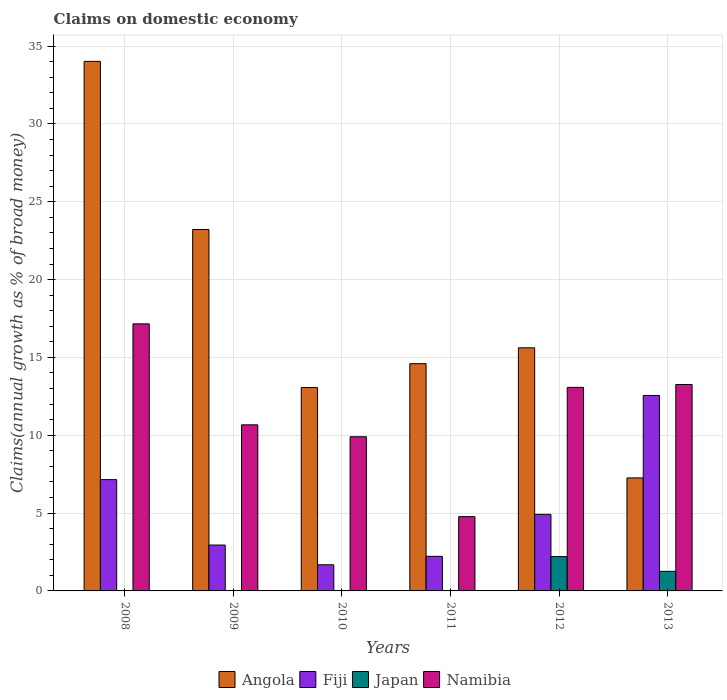In how many cases, is the number of bars for a given year not equal to the number of legend labels?
Ensure brevity in your answer.  4. What is the percentage of broad money claimed on domestic economy in Angola in 2012?
Provide a succinct answer. 15.62. Across all years, what is the maximum percentage of broad money claimed on domestic economy in Angola?
Your answer should be very brief. 34.02. Across all years, what is the minimum percentage of broad money claimed on domestic economy in Namibia?
Keep it short and to the point. 4.77. In which year was the percentage of broad money claimed on domestic economy in Namibia maximum?
Offer a terse response. 2008. What is the total percentage of broad money claimed on domestic economy in Fiji in the graph?
Ensure brevity in your answer.  31.47. What is the difference between the percentage of broad money claimed on domestic economy in Angola in 2010 and that in 2011?
Offer a terse response. -1.53. What is the difference between the percentage of broad money claimed on domestic economy in Fiji in 2008 and the percentage of broad money claimed on domestic economy in Namibia in 2009?
Ensure brevity in your answer.  -3.52. What is the average percentage of broad money claimed on domestic economy in Fiji per year?
Provide a short and direct response. 5.25. In the year 2013, what is the difference between the percentage of broad money claimed on domestic economy in Namibia and percentage of broad money claimed on domestic economy in Japan?
Make the answer very short. 12. In how many years, is the percentage of broad money claimed on domestic economy in Namibia greater than 24 %?
Ensure brevity in your answer.  0. What is the ratio of the percentage of broad money claimed on domestic economy in Namibia in 2009 to that in 2013?
Ensure brevity in your answer.  0.8. Is the percentage of broad money claimed on domestic economy in Namibia in 2010 less than that in 2011?
Ensure brevity in your answer.  No. What is the difference between the highest and the second highest percentage of broad money claimed on domestic economy in Namibia?
Your response must be concise. 3.9. What is the difference between the highest and the lowest percentage of broad money claimed on domestic economy in Angola?
Offer a terse response. 26.76. Is the sum of the percentage of broad money claimed on domestic economy in Fiji in 2012 and 2013 greater than the maximum percentage of broad money claimed on domestic economy in Japan across all years?
Provide a short and direct response. Yes. Is it the case that in every year, the sum of the percentage of broad money claimed on domestic economy in Japan and percentage of broad money claimed on domestic economy in Angola is greater than the sum of percentage of broad money claimed on domestic economy in Fiji and percentage of broad money claimed on domestic economy in Namibia?
Your response must be concise. Yes. How many bars are there?
Provide a succinct answer. 20. How many legend labels are there?
Your answer should be compact. 4. What is the title of the graph?
Provide a succinct answer. Claims on domestic economy. What is the label or title of the X-axis?
Provide a succinct answer. Years. What is the label or title of the Y-axis?
Your response must be concise. Claims(annual growth as % of broad money). What is the Claims(annual growth as % of broad money) of Angola in 2008?
Your response must be concise. 34.02. What is the Claims(annual growth as % of broad money) of Fiji in 2008?
Ensure brevity in your answer.  7.15. What is the Claims(annual growth as % of broad money) of Japan in 2008?
Your response must be concise. 0. What is the Claims(annual growth as % of broad money) in Namibia in 2008?
Your response must be concise. 17.15. What is the Claims(annual growth as % of broad money) of Angola in 2009?
Offer a very short reply. 23.22. What is the Claims(annual growth as % of broad money) of Fiji in 2009?
Ensure brevity in your answer.  2.95. What is the Claims(annual growth as % of broad money) of Japan in 2009?
Your answer should be compact. 0. What is the Claims(annual growth as % of broad money) in Namibia in 2009?
Provide a succinct answer. 10.67. What is the Claims(annual growth as % of broad money) in Angola in 2010?
Keep it short and to the point. 13.06. What is the Claims(annual growth as % of broad money) of Fiji in 2010?
Provide a short and direct response. 1.68. What is the Claims(annual growth as % of broad money) in Japan in 2010?
Give a very brief answer. 0. What is the Claims(annual growth as % of broad money) in Namibia in 2010?
Give a very brief answer. 9.9. What is the Claims(annual growth as % of broad money) of Angola in 2011?
Keep it short and to the point. 14.6. What is the Claims(annual growth as % of broad money) of Fiji in 2011?
Your response must be concise. 2.22. What is the Claims(annual growth as % of broad money) of Namibia in 2011?
Ensure brevity in your answer.  4.77. What is the Claims(annual growth as % of broad money) of Angola in 2012?
Your response must be concise. 15.62. What is the Claims(annual growth as % of broad money) in Fiji in 2012?
Provide a short and direct response. 4.92. What is the Claims(annual growth as % of broad money) in Japan in 2012?
Make the answer very short. 2.21. What is the Claims(annual growth as % of broad money) of Namibia in 2012?
Offer a terse response. 13.08. What is the Claims(annual growth as % of broad money) in Angola in 2013?
Keep it short and to the point. 7.26. What is the Claims(annual growth as % of broad money) of Fiji in 2013?
Provide a short and direct response. 12.56. What is the Claims(annual growth as % of broad money) in Japan in 2013?
Provide a succinct answer. 1.26. What is the Claims(annual growth as % of broad money) of Namibia in 2013?
Provide a short and direct response. 13.26. Across all years, what is the maximum Claims(annual growth as % of broad money) in Angola?
Your answer should be compact. 34.02. Across all years, what is the maximum Claims(annual growth as % of broad money) in Fiji?
Your answer should be compact. 12.56. Across all years, what is the maximum Claims(annual growth as % of broad money) of Japan?
Your answer should be very brief. 2.21. Across all years, what is the maximum Claims(annual growth as % of broad money) of Namibia?
Provide a succinct answer. 17.15. Across all years, what is the minimum Claims(annual growth as % of broad money) in Angola?
Offer a terse response. 7.26. Across all years, what is the minimum Claims(annual growth as % of broad money) of Fiji?
Keep it short and to the point. 1.68. Across all years, what is the minimum Claims(annual growth as % of broad money) of Japan?
Your answer should be compact. 0. Across all years, what is the minimum Claims(annual growth as % of broad money) of Namibia?
Provide a short and direct response. 4.77. What is the total Claims(annual growth as % of broad money) of Angola in the graph?
Keep it short and to the point. 107.77. What is the total Claims(annual growth as % of broad money) in Fiji in the graph?
Your answer should be very brief. 31.47. What is the total Claims(annual growth as % of broad money) of Japan in the graph?
Your answer should be compact. 3.46. What is the total Claims(annual growth as % of broad money) of Namibia in the graph?
Offer a very short reply. 68.83. What is the difference between the Claims(annual growth as % of broad money) of Angola in 2008 and that in 2009?
Your answer should be compact. 10.8. What is the difference between the Claims(annual growth as % of broad money) in Fiji in 2008 and that in 2009?
Your answer should be very brief. 4.2. What is the difference between the Claims(annual growth as % of broad money) of Namibia in 2008 and that in 2009?
Give a very brief answer. 6.49. What is the difference between the Claims(annual growth as % of broad money) in Angola in 2008 and that in 2010?
Provide a short and direct response. 20.95. What is the difference between the Claims(annual growth as % of broad money) in Fiji in 2008 and that in 2010?
Your answer should be very brief. 5.47. What is the difference between the Claims(annual growth as % of broad money) of Namibia in 2008 and that in 2010?
Your answer should be compact. 7.25. What is the difference between the Claims(annual growth as % of broad money) of Angola in 2008 and that in 2011?
Give a very brief answer. 19.42. What is the difference between the Claims(annual growth as % of broad money) of Fiji in 2008 and that in 2011?
Your answer should be compact. 4.93. What is the difference between the Claims(annual growth as % of broad money) of Namibia in 2008 and that in 2011?
Ensure brevity in your answer.  12.38. What is the difference between the Claims(annual growth as % of broad money) in Angola in 2008 and that in 2012?
Give a very brief answer. 18.4. What is the difference between the Claims(annual growth as % of broad money) of Fiji in 2008 and that in 2012?
Offer a terse response. 2.23. What is the difference between the Claims(annual growth as % of broad money) of Namibia in 2008 and that in 2012?
Offer a terse response. 4.08. What is the difference between the Claims(annual growth as % of broad money) of Angola in 2008 and that in 2013?
Your response must be concise. 26.76. What is the difference between the Claims(annual growth as % of broad money) of Fiji in 2008 and that in 2013?
Provide a succinct answer. -5.41. What is the difference between the Claims(annual growth as % of broad money) of Namibia in 2008 and that in 2013?
Your answer should be very brief. 3.9. What is the difference between the Claims(annual growth as % of broad money) in Angola in 2009 and that in 2010?
Your response must be concise. 10.15. What is the difference between the Claims(annual growth as % of broad money) of Fiji in 2009 and that in 2010?
Provide a succinct answer. 1.27. What is the difference between the Claims(annual growth as % of broad money) of Namibia in 2009 and that in 2010?
Your response must be concise. 0.77. What is the difference between the Claims(annual growth as % of broad money) of Angola in 2009 and that in 2011?
Keep it short and to the point. 8.62. What is the difference between the Claims(annual growth as % of broad money) in Fiji in 2009 and that in 2011?
Provide a short and direct response. 0.72. What is the difference between the Claims(annual growth as % of broad money) of Namibia in 2009 and that in 2011?
Give a very brief answer. 5.9. What is the difference between the Claims(annual growth as % of broad money) in Angola in 2009 and that in 2012?
Provide a short and direct response. 7.6. What is the difference between the Claims(annual growth as % of broad money) of Fiji in 2009 and that in 2012?
Make the answer very short. -1.97. What is the difference between the Claims(annual growth as % of broad money) of Namibia in 2009 and that in 2012?
Keep it short and to the point. -2.41. What is the difference between the Claims(annual growth as % of broad money) in Angola in 2009 and that in 2013?
Give a very brief answer. 15.96. What is the difference between the Claims(annual growth as % of broad money) in Fiji in 2009 and that in 2013?
Keep it short and to the point. -9.61. What is the difference between the Claims(annual growth as % of broad money) in Namibia in 2009 and that in 2013?
Give a very brief answer. -2.59. What is the difference between the Claims(annual growth as % of broad money) in Angola in 2010 and that in 2011?
Provide a succinct answer. -1.53. What is the difference between the Claims(annual growth as % of broad money) of Fiji in 2010 and that in 2011?
Your response must be concise. -0.54. What is the difference between the Claims(annual growth as % of broad money) of Namibia in 2010 and that in 2011?
Ensure brevity in your answer.  5.13. What is the difference between the Claims(annual growth as % of broad money) in Angola in 2010 and that in 2012?
Make the answer very short. -2.55. What is the difference between the Claims(annual growth as % of broad money) in Fiji in 2010 and that in 2012?
Your answer should be compact. -3.24. What is the difference between the Claims(annual growth as % of broad money) of Namibia in 2010 and that in 2012?
Your response must be concise. -3.17. What is the difference between the Claims(annual growth as % of broad money) of Angola in 2010 and that in 2013?
Offer a terse response. 5.8. What is the difference between the Claims(annual growth as % of broad money) in Fiji in 2010 and that in 2013?
Make the answer very short. -10.88. What is the difference between the Claims(annual growth as % of broad money) in Namibia in 2010 and that in 2013?
Your response must be concise. -3.35. What is the difference between the Claims(annual growth as % of broad money) in Angola in 2011 and that in 2012?
Provide a succinct answer. -1.02. What is the difference between the Claims(annual growth as % of broad money) of Fiji in 2011 and that in 2012?
Provide a short and direct response. -2.7. What is the difference between the Claims(annual growth as % of broad money) in Namibia in 2011 and that in 2012?
Keep it short and to the point. -8.3. What is the difference between the Claims(annual growth as % of broad money) in Angola in 2011 and that in 2013?
Give a very brief answer. 7.34. What is the difference between the Claims(annual growth as % of broad money) of Fiji in 2011 and that in 2013?
Make the answer very short. -10.33. What is the difference between the Claims(annual growth as % of broad money) in Namibia in 2011 and that in 2013?
Keep it short and to the point. -8.49. What is the difference between the Claims(annual growth as % of broad money) of Angola in 2012 and that in 2013?
Offer a very short reply. 8.36. What is the difference between the Claims(annual growth as % of broad money) of Fiji in 2012 and that in 2013?
Your response must be concise. -7.64. What is the difference between the Claims(annual growth as % of broad money) of Japan in 2012 and that in 2013?
Make the answer very short. 0.95. What is the difference between the Claims(annual growth as % of broad money) in Namibia in 2012 and that in 2013?
Your response must be concise. -0.18. What is the difference between the Claims(annual growth as % of broad money) in Angola in 2008 and the Claims(annual growth as % of broad money) in Fiji in 2009?
Your answer should be very brief. 31.07. What is the difference between the Claims(annual growth as % of broad money) in Angola in 2008 and the Claims(annual growth as % of broad money) in Namibia in 2009?
Offer a terse response. 23.35. What is the difference between the Claims(annual growth as % of broad money) of Fiji in 2008 and the Claims(annual growth as % of broad money) of Namibia in 2009?
Provide a short and direct response. -3.52. What is the difference between the Claims(annual growth as % of broad money) in Angola in 2008 and the Claims(annual growth as % of broad money) in Fiji in 2010?
Your answer should be compact. 32.34. What is the difference between the Claims(annual growth as % of broad money) of Angola in 2008 and the Claims(annual growth as % of broad money) of Namibia in 2010?
Make the answer very short. 24.11. What is the difference between the Claims(annual growth as % of broad money) of Fiji in 2008 and the Claims(annual growth as % of broad money) of Namibia in 2010?
Your response must be concise. -2.75. What is the difference between the Claims(annual growth as % of broad money) in Angola in 2008 and the Claims(annual growth as % of broad money) in Fiji in 2011?
Make the answer very short. 31.8. What is the difference between the Claims(annual growth as % of broad money) in Angola in 2008 and the Claims(annual growth as % of broad money) in Namibia in 2011?
Provide a succinct answer. 29.25. What is the difference between the Claims(annual growth as % of broad money) in Fiji in 2008 and the Claims(annual growth as % of broad money) in Namibia in 2011?
Keep it short and to the point. 2.38. What is the difference between the Claims(annual growth as % of broad money) in Angola in 2008 and the Claims(annual growth as % of broad money) in Fiji in 2012?
Provide a succinct answer. 29.1. What is the difference between the Claims(annual growth as % of broad money) of Angola in 2008 and the Claims(annual growth as % of broad money) of Japan in 2012?
Offer a terse response. 31.81. What is the difference between the Claims(annual growth as % of broad money) of Angola in 2008 and the Claims(annual growth as % of broad money) of Namibia in 2012?
Provide a succinct answer. 20.94. What is the difference between the Claims(annual growth as % of broad money) of Fiji in 2008 and the Claims(annual growth as % of broad money) of Japan in 2012?
Provide a short and direct response. 4.94. What is the difference between the Claims(annual growth as % of broad money) of Fiji in 2008 and the Claims(annual growth as % of broad money) of Namibia in 2012?
Your response must be concise. -5.93. What is the difference between the Claims(annual growth as % of broad money) in Angola in 2008 and the Claims(annual growth as % of broad money) in Fiji in 2013?
Your response must be concise. 21.46. What is the difference between the Claims(annual growth as % of broad money) of Angola in 2008 and the Claims(annual growth as % of broad money) of Japan in 2013?
Your answer should be compact. 32.76. What is the difference between the Claims(annual growth as % of broad money) of Angola in 2008 and the Claims(annual growth as % of broad money) of Namibia in 2013?
Your response must be concise. 20.76. What is the difference between the Claims(annual growth as % of broad money) in Fiji in 2008 and the Claims(annual growth as % of broad money) in Japan in 2013?
Your answer should be very brief. 5.89. What is the difference between the Claims(annual growth as % of broad money) in Fiji in 2008 and the Claims(annual growth as % of broad money) in Namibia in 2013?
Make the answer very short. -6.11. What is the difference between the Claims(annual growth as % of broad money) of Angola in 2009 and the Claims(annual growth as % of broad money) of Fiji in 2010?
Make the answer very short. 21.54. What is the difference between the Claims(annual growth as % of broad money) in Angola in 2009 and the Claims(annual growth as % of broad money) in Namibia in 2010?
Offer a very short reply. 13.31. What is the difference between the Claims(annual growth as % of broad money) in Fiji in 2009 and the Claims(annual growth as % of broad money) in Namibia in 2010?
Offer a very short reply. -6.96. What is the difference between the Claims(annual growth as % of broad money) of Angola in 2009 and the Claims(annual growth as % of broad money) of Fiji in 2011?
Offer a very short reply. 20.99. What is the difference between the Claims(annual growth as % of broad money) of Angola in 2009 and the Claims(annual growth as % of broad money) of Namibia in 2011?
Provide a short and direct response. 18.45. What is the difference between the Claims(annual growth as % of broad money) of Fiji in 2009 and the Claims(annual growth as % of broad money) of Namibia in 2011?
Your answer should be compact. -1.82. What is the difference between the Claims(annual growth as % of broad money) in Angola in 2009 and the Claims(annual growth as % of broad money) in Fiji in 2012?
Your answer should be compact. 18.3. What is the difference between the Claims(annual growth as % of broad money) in Angola in 2009 and the Claims(annual growth as % of broad money) in Japan in 2012?
Provide a succinct answer. 21.01. What is the difference between the Claims(annual growth as % of broad money) of Angola in 2009 and the Claims(annual growth as % of broad money) of Namibia in 2012?
Your answer should be compact. 10.14. What is the difference between the Claims(annual growth as % of broad money) of Fiji in 2009 and the Claims(annual growth as % of broad money) of Japan in 2012?
Your answer should be very brief. 0.74. What is the difference between the Claims(annual growth as % of broad money) in Fiji in 2009 and the Claims(annual growth as % of broad money) in Namibia in 2012?
Your response must be concise. -10.13. What is the difference between the Claims(annual growth as % of broad money) in Angola in 2009 and the Claims(annual growth as % of broad money) in Fiji in 2013?
Offer a very short reply. 10.66. What is the difference between the Claims(annual growth as % of broad money) in Angola in 2009 and the Claims(annual growth as % of broad money) in Japan in 2013?
Provide a short and direct response. 21.96. What is the difference between the Claims(annual growth as % of broad money) in Angola in 2009 and the Claims(annual growth as % of broad money) in Namibia in 2013?
Your answer should be compact. 9.96. What is the difference between the Claims(annual growth as % of broad money) of Fiji in 2009 and the Claims(annual growth as % of broad money) of Japan in 2013?
Provide a short and direct response. 1.69. What is the difference between the Claims(annual growth as % of broad money) of Fiji in 2009 and the Claims(annual growth as % of broad money) of Namibia in 2013?
Your response must be concise. -10.31. What is the difference between the Claims(annual growth as % of broad money) of Angola in 2010 and the Claims(annual growth as % of broad money) of Fiji in 2011?
Your answer should be compact. 10.84. What is the difference between the Claims(annual growth as % of broad money) in Angola in 2010 and the Claims(annual growth as % of broad money) in Namibia in 2011?
Provide a succinct answer. 8.29. What is the difference between the Claims(annual growth as % of broad money) in Fiji in 2010 and the Claims(annual growth as % of broad money) in Namibia in 2011?
Give a very brief answer. -3.09. What is the difference between the Claims(annual growth as % of broad money) in Angola in 2010 and the Claims(annual growth as % of broad money) in Fiji in 2012?
Offer a very short reply. 8.14. What is the difference between the Claims(annual growth as % of broad money) of Angola in 2010 and the Claims(annual growth as % of broad money) of Japan in 2012?
Your answer should be very brief. 10.86. What is the difference between the Claims(annual growth as % of broad money) of Angola in 2010 and the Claims(annual growth as % of broad money) of Namibia in 2012?
Your response must be concise. -0.01. What is the difference between the Claims(annual growth as % of broad money) in Fiji in 2010 and the Claims(annual growth as % of broad money) in Japan in 2012?
Provide a short and direct response. -0.53. What is the difference between the Claims(annual growth as % of broad money) in Fiji in 2010 and the Claims(annual growth as % of broad money) in Namibia in 2012?
Your answer should be very brief. -11.4. What is the difference between the Claims(annual growth as % of broad money) of Angola in 2010 and the Claims(annual growth as % of broad money) of Fiji in 2013?
Provide a short and direct response. 0.51. What is the difference between the Claims(annual growth as % of broad money) of Angola in 2010 and the Claims(annual growth as % of broad money) of Japan in 2013?
Your response must be concise. 11.8. What is the difference between the Claims(annual growth as % of broad money) in Angola in 2010 and the Claims(annual growth as % of broad money) in Namibia in 2013?
Offer a very short reply. -0.2. What is the difference between the Claims(annual growth as % of broad money) in Fiji in 2010 and the Claims(annual growth as % of broad money) in Japan in 2013?
Your answer should be compact. 0.42. What is the difference between the Claims(annual growth as % of broad money) in Fiji in 2010 and the Claims(annual growth as % of broad money) in Namibia in 2013?
Make the answer very short. -11.58. What is the difference between the Claims(annual growth as % of broad money) in Angola in 2011 and the Claims(annual growth as % of broad money) in Fiji in 2012?
Make the answer very short. 9.68. What is the difference between the Claims(annual growth as % of broad money) in Angola in 2011 and the Claims(annual growth as % of broad money) in Japan in 2012?
Provide a succinct answer. 12.39. What is the difference between the Claims(annual growth as % of broad money) in Angola in 2011 and the Claims(annual growth as % of broad money) in Namibia in 2012?
Ensure brevity in your answer.  1.52. What is the difference between the Claims(annual growth as % of broad money) in Fiji in 2011 and the Claims(annual growth as % of broad money) in Japan in 2012?
Keep it short and to the point. 0.02. What is the difference between the Claims(annual growth as % of broad money) of Fiji in 2011 and the Claims(annual growth as % of broad money) of Namibia in 2012?
Your response must be concise. -10.85. What is the difference between the Claims(annual growth as % of broad money) in Angola in 2011 and the Claims(annual growth as % of broad money) in Fiji in 2013?
Make the answer very short. 2.04. What is the difference between the Claims(annual growth as % of broad money) in Angola in 2011 and the Claims(annual growth as % of broad money) in Japan in 2013?
Your response must be concise. 13.34. What is the difference between the Claims(annual growth as % of broad money) of Angola in 2011 and the Claims(annual growth as % of broad money) of Namibia in 2013?
Provide a succinct answer. 1.34. What is the difference between the Claims(annual growth as % of broad money) of Fiji in 2011 and the Claims(annual growth as % of broad money) of Japan in 2013?
Your response must be concise. 0.96. What is the difference between the Claims(annual growth as % of broad money) of Fiji in 2011 and the Claims(annual growth as % of broad money) of Namibia in 2013?
Ensure brevity in your answer.  -11.04. What is the difference between the Claims(annual growth as % of broad money) of Angola in 2012 and the Claims(annual growth as % of broad money) of Fiji in 2013?
Keep it short and to the point. 3.06. What is the difference between the Claims(annual growth as % of broad money) of Angola in 2012 and the Claims(annual growth as % of broad money) of Japan in 2013?
Ensure brevity in your answer.  14.36. What is the difference between the Claims(annual growth as % of broad money) in Angola in 2012 and the Claims(annual growth as % of broad money) in Namibia in 2013?
Give a very brief answer. 2.36. What is the difference between the Claims(annual growth as % of broad money) of Fiji in 2012 and the Claims(annual growth as % of broad money) of Japan in 2013?
Keep it short and to the point. 3.66. What is the difference between the Claims(annual growth as % of broad money) in Fiji in 2012 and the Claims(annual growth as % of broad money) in Namibia in 2013?
Your response must be concise. -8.34. What is the difference between the Claims(annual growth as % of broad money) of Japan in 2012 and the Claims(annual growth as % of broad money) of Namibia in 2013?
Provide a short and direct response. -11.05. What is the average Claims(annual growth as % of broad money) in Angola per year?
Ensure brevity in your answer.  17.96. What is the average Claims(annual growth as % of broad money) of Fiji per year?
Offer a very short reply. 5.25. What is the average Claims(annual growth as % of broad money) of Japan per year?
Keep it short and to the point. 0.58. What is the average Claims(annual growth as % of broad money) of Namibia per year?
Provide a succinct answer. 11.47. In the year 2008, what is the difference between the Claims(annual growth as % of broad money) in Angola and Claims(annual growth as % of broad money) in Fiji?
Offer a terse response. 26.87. In the year 2008, what is the difference between the Claims(annual growth as % of broad money) of Angola and Claims(annual growth as % of broad money) of Namibia?
Offer a very short reply. 16.86. In the year 2008, what is the difference between the Claims(annual growth as % of broad money) of Fiji and Claims(annual growth as % of broad money) of Namibia?
Ensure brevity in your answer.  -10. In the year 2009, what is the difference between the Claims(annual growth as % of broad money) in Angola and Claims(annual growth as % of broad money) in Fiji?
Offer a very short reply. 20.27. In the year 2009, what is the difference between the Claims(annual growth as % of broad money) of Angola and Claims(annual growth as % of broad money) of Namibia?
Your response must be concise. 12.55. In the year 2009, what is the difference between the Claims(annual growth as % of broad money) of Fiji and Claims(annual growth as % of broad money) of Namibia?
Offer a very short reply. -7.72. In the year 2010, what is the difference between the Claims(annual growth as % of broad money) in Angola and Claims(annual growth as % of broad money) in Fiji?
Offer a very short reply. 11.38. In the year 2010, what is the difference between the Claims(annual growth as % of broad money) in Angola and Claims(annual growth as % of broad money) in Namibia?
Provide a short and direct response. 3.16. In the year 2010, what is the difference between the Claims(annual growth as % of broad money) of Fiji and Claims(annual growth as % of broad money) of Namibia?
Provide a short and direct response. -8.22. In the year 2011, what is the difference between the Claims(annual growth as % of broad money) in Angola and Claims(annual growth as % of broad money) in Fiji?
Offer a terse response. 12.37. In the year 2011, what is the difference between the Claims(annual growth as % of broad money) of Angola and Claims(annual growth as % of broad money) of Namibia?
Provide a short and direct response. 9.83. In the year 2011, what is the difference between the Claims(annual growth as % of broad money) in Fiji and Claims(annual growth as % of broad money) in Namibia?
Your answer should be compact. -2.55. In the year 2012, what is the difference between the Claims(annual growth as % of broad money) of Angola and Claims(annual growth as % of broad money) of Fiji?
Offer a very short reply. 10.7. In the year 2012, what is the difference between the Claims(annual growth as % of broad money) in Angola and Claims(annual growth as % of broad money) in Japan?
Your answer should be very brief. 13.41. In the year 2012, what is the difference between the Claims(annual growth as % of broad money) of Angola and Claims(annual growth as % of broad money) of Namibia?
Keep it short and to the point. 2.54. In the year 2012, what is the difference between the Claims(annual growth as % of broad money) in Fiji and Claims(annual growth as % of broad money) in Japan?
Your answer should be very brief. 2.71. In the year 2012, what is the difference between the Claims(annual growth as % of broad money) of Fiji and Claims(annual growth as % of broad money) of Namibia?
Offer a terse response. -8.16. In the year 2012, what is the difference between the Claims(annual growth as % of broad money) of Japan and Claims(annual growth as % of broad money) of Namibia?
Keep it short and to the point. -10.87. In the year 2013, what is the difference between the Claims(annual growth as % of broad money) in Angola and Claims(annual growth as % of broad money) in Fiji?
Offer a very short reply. -5.3. In the year 2013, what is the difference between the Claims(annual growth as % of broad money) of Angola and Claims(annual growth as % of broad money) of Japan?
Ensure brevity in your answer.  6. In the year 2013, what is the difference between the Claims(annual growth as % of broad money) of Angola and Claims(annual growth as % of broad money) of Namibia?
Keep it short and to the point. -6. In the year 2013, what is the difference between the Claims(annual growth as % of broad money) of Fiji and Claims(annual growth as % of broad money) of Japan?
Give a very brief answer. 11.3. In the year 2013, what is the difference between the Claims(annual growth as % of broad money) in Fiji and Claims(annual growth as % of broad money) in Namibia?
Offer a terse response. -0.7. In the year 2013, what is the difference between the Claims(annual growth as % of broad money) in Japan and Claims(annual growth as % of broad money) in Namibia?
Offer a very short reply. -12. What is the ratio of the Claims(annual growth as % of broad money) of Angola in 2008 to that in 2009?
Offer a very short reply. 1.47. What is the ratio of the Claims(annual growth as % of broad money) of Fiji in 2008 to that in 2009?
Your response must be concise. 2.43. What is the ratio of the Claims(annual growth as % of broad money) of Namibia in 2008 to that in 2009?
Offer a very short reply. 1.61. What is the ratio of the Claims(annual growth as % of broad money) of Angola in 2008 to that in 2010?
Your response must be concise. 2.6. What is the ratio of the Claims(annual growth as % of broad money) in Fiji in 2008 to that in 2010?
Offer a very short reply. 4.26. What is the ratio of the Claims(annual growth as % of broad money) in Namibia in 2008 to that in 2010?
Your response must be concise. 1.73. What is the ratio of the Claims(annual growth as % of broad money) of Angola in 2008 to that in 2011?
Your answer should be very brief. 2.33. What is the ratio of the Claims(annual growth as % of broad money) of Fiji in 2008 to that in 2011?
Offer a terse response. 3.22. What is the ratio of the Claims(annual growth as % of broad money) in Namibia in 2008 to that in 2011?
Your answer should be very brief. 3.6. What is the ratio of the Claims(annual growth as % of broad money) in Angola in 2008 to that in 2012?
Offer a terse response. 2.18. What is the ratio of the Claims(annual growth as % of broad money) in Fiji in 2008 to that in 2012?
Provide a succinct answer. 1.45. What is the ratio of the Claims(annual growth as % of broad money) of Namibia in 2008 to that in 2012?
Your response must be concise. 1.31. What is the ratio of the Claims(annual growth as % of broad money) in Angola in 2008 to that in 2013?
Ensure brevity in your answer.  4.69. What is the ratio of the Claims(annual growth as % of broad money) of Fiji in 2008 to that in 2013?
Your answer should be very brief. 0.57. What is the ratio of the Claims(annual growth as % of broad money) in Namibia in 2008 to that in 2013?
Your answer should be very brief. 1.29. What is the ratio of the Claims(annual growth as % of broad money) of Angola in 2009 to that in 2010?
Provide a succinct answer. 1.78. What is the ratio of the Claims(annual growth as % of broad money) of Fiji in 2009 to that in 2010?
Make the answer very short. 1.75. What is the ratio of the Claims(annual growth as % of broad money) of Namibia in 2009 to that in 2010?
Provide a short and direct response. 1.08. What is the ratio of the Claims(annual growth as % of broad money) in Angola in 2009 to that in 2011?
Make the answer very short. 1.59. What is the ratio of the Claims(annual growth as % of broad money) in Fiji in 2009 to that in 2011?
Provide a succinct answer. 1.33. What is the ratio of the Claims(annual growth as % of broad money) of Namibia in 2009 to that in 2011?
Your answer should be very brief. 2.24. What is the ratio of the Claims(annual growth as % of broad money) of Angola in 2009 to that in 2012?
Give a very brief answer. 1.49. What is the ratio of the Claims(annual growth as % of broad money) of Fiji in 2009 to that in 2012?
Make the answer very short. 0.6. What is the ratio of the Claims(annual growth as % of broad money) in Namibia in 2009 to that in 2012?
Make the answer very short. 0.82. What is the ratio of the Claims(annual growth as % of broad money) in Angola in 2009 to that in 2013?
Offer a terse response. 3.2. What is the ratio of the Claims(annual growth as % of broad money) in Fiji in 2009 to that in 2013?
Give a very brief answer. 0.23. What is the ratio of the Claims(annual growth as % of broad money) in Namibia in 2009 to that in 2013?
Your answer should be very brief. 0.8. What is the ratio of the Claims(annual growth as % of broad money) of Angola in 2010 to that in 2011?
Give a very brief answer. 0.9. What is the ratio of the Claims(annual growth as % of broad money) in Fiji in 2010 to that in 2011?
Your response must be concise. 0.76. What is the ratio of the Claims(annual growth as % of broad money) of Namibia in 2010 to that in 2011?
Offer a very short reply. 2.08. What is the ratio of the Claims(annual growth as % of broad money) in Angola in 2010 to that in 2012?
Offer a very short reply. 0.84. What is the ratio of the Claims(annual growth as % of broad money) of Fiji in 2010 to that in 2012?
Keep it short and to the point. 0.34. What is the ratio of the Claims(annual growth as % of broad money) in Namibia in 2010 to that in 2012?
Your response must be concise. 0.76. What is the ratio of the Claims(annual growth as % of broad money) in Angola in 2010 to that in 2013?
Ensure brevity in your answer.  1.8. What is the ratio of the Claims(annual growth as % of broad money) of Fiji in 2010 to that in 2013?
Ensure brevity in your answer.  0.13. What is the ratio of the Claims(annual growth as % of broad money) in Namibia in 2010 to that in 2013?
Your response must be concise. 0.75. What is the ratio of the Claims(annual growth as % of broad money) in Angola in 2011 to that in 2012?
Keep it short and to the point. 0.93. What is the ratio of the Claims(annual growth as % of broad money) in Fiji in 2011 to that in 2012?
Your answer should be very brief. 0.45. What is the ratio of the Claims(annual growth as % of broad money) in Namibia in 2011 to that in 2012?
Offer a very short reply. 0.36. What is the ratio of the Claims(annual growth as % of broad money) in Angola in 2011 to that in 2013?
Offer a very short reply. 2.01. What is the ratio of the Claims(annual growth as % of broad money) of Fiji in 2011 to that in 2013?
Your answer should be very brief. 0.18. What is the ratio of the Claims(annual growth as % of broad money) of Namibia in 2011 to that in 2013?
Provide a succinct answer. 0.36. What is the ratio of the Claims(annual growth as % of broad money) of Angola in 2012 to that in 2013?
Make the answer very short. 2.15. What is the ratio of the Claims(annual growth as % of broad money) of Fiji in 2012 to that in 2013?
Your answer should be very brief. 0.39. What is the ratio of the Claims(annual growth as % of broad money) of Japan in 2012 to that in 2013?
Give a very brief answer. 1.75. What is the ratio of the Claims(annual growth as % of broad money) in Namibia in 2012 to that in 2013?
Provide a succinct answer. 0.99. What is the difference between the highest and the second highest Claims(annual growth as % of broad money) of Angola?
Provide a succinct answer. 10.8. What is the difference between the highest and the second highest Claims(annual growth as % of broad money) in Fiji?
Your response must be concise. 5.41. What is the difference between the highest and the second highest Claims(annual growth as % of broad money) in Namibia?
Make the answer very short. 3.9. What is the difference between the highest and the lowest Claims(annual growth as % of broad money) in Angola?
Give a very brief answer. 26.76. What is the difference between the highest and the lowest Claims(annual growth as % of broad money) in Fiji?
Provide a short and direct response. 10.88. What is the difference between the highest and the lowest Claims(annual growth as % of broad money) in Japan?
Provide a short and direct response. 2.21. What is the difference between the highest and the lowest Claims(annual growth as % of broad money) of Namibia?
Offer a terse response. 12.38. 